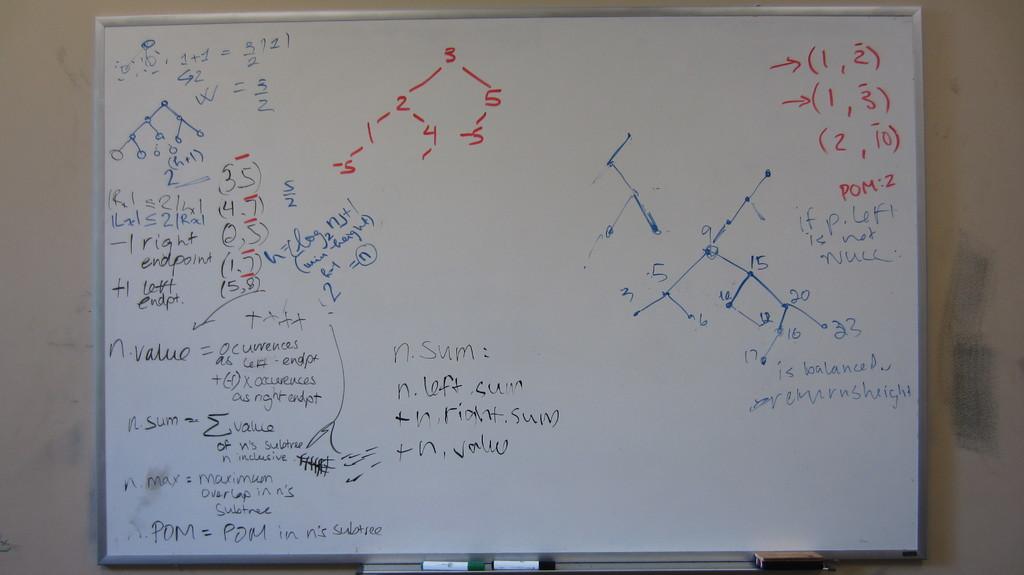What are the numbers in red on the right of the board?
Your response must be concise. 1 2 3 2 10. 